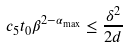<formula> <loc_0><loc_0><loc_500><loc_500>c _ { 5 } t _ { 0 } \beta ^ { 2 - \alpha _ { \max } } \leq \frac { \delta ^ { 2 } } { 2 d }</formula> 